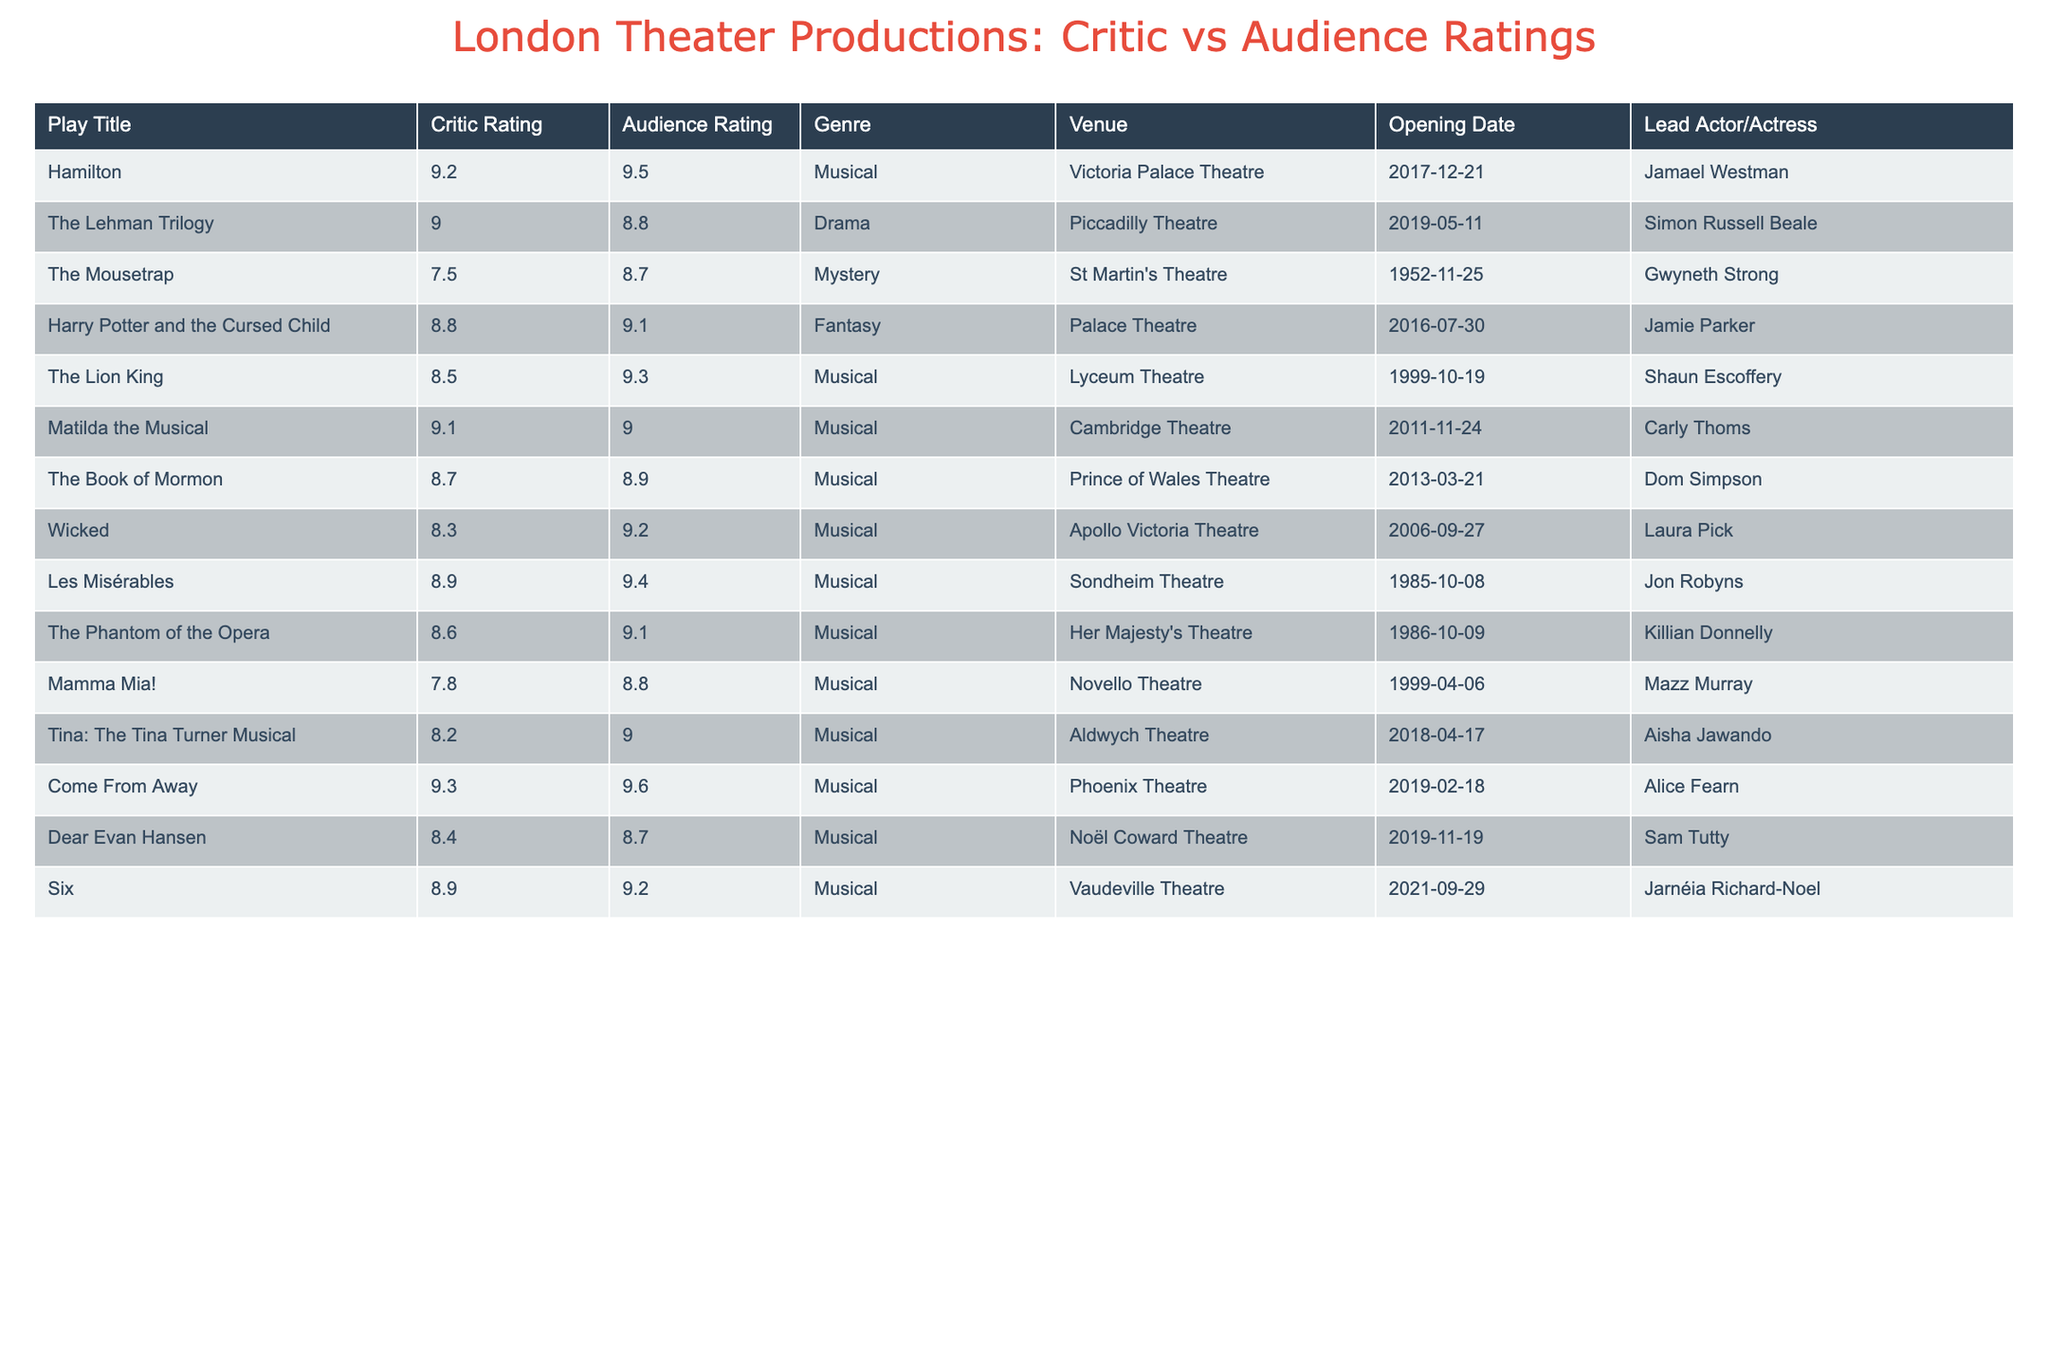What is the highest critic rating among the listed plays? The highest critic rating is found by looking at the Critic Rating column and identifying the maximum value, which is 9.3 for "Come From Away."
Answer: 9.3 Which play has the lowest audience rating? The lowest audience rating can be found in the Audience Rating column. The play with the lowest value is "Mamma Mia!" with a rating of 8.8.
Answer: 8.8 Is the audience rating for "The Lion King" higher than 9.0? Checking the Audience Rating for "The Lion King," it is 9.3, which is indeed higher than 9.0.
Answer: Yes What is the difference between the critic rating and audience rating for "The Lehman Trilogy"? For "The Lehman Trilogy," the critic rating is 9.0 and the audience rating is 8.8. The difference can be calculated as 9.0 - 8.8 = 0.2.
Answer: 0.2 Which genre has the highest average critic rating? To find the average critic rating by genre, we need to sum the critic ratings for each genre and then divide by the number of plays in that genre. The averages are: Musicals = 8.74, Drama = 9.00, Mystery = 7.5, Fantasy = 8.8. The highest average is for Drama.
Answer: Drama What is the audience rating for "Harry Potter and the Cursed Child"? The Audience Rating for "Harry Potter and the Cursed Child" is explicitly stated in the table as 9.1.
Answer: 9.1 Are there any plays where the audience rating is greater than the critic rating? We can compare the values of Critic and Audience Ratings across all plays. The plays "Come From Away," "Hamilton," "Harry Potter and the Cursed Child," "Les Misérables," "The Lion King," "Mamma Mia!," "Six," and "Tina: The Tina Turner Musical" show audience ratings greater than their critic ratings.
Answer: Yes Which play features a lead actor or actress named "Laura Pick"? Referring to the Lead Actor/Actress column, "Wicked" features Laura Pick in the lead role.
Answer: Wicked What is the median critic rating of all the plays listed? We need to arrange the Critic Ratings in ascending order and find the median value. The ratings sorted are: 7.5, 7.8, 8.2, 8.3, 8.4, 8.5, 8.6, 8.7, 8.8, 8.9, 9.0, 9.1, 9.2, 9.3. With 14 values, the median is the average of the 7th and 8th values: (8.6 + 8.7) / 2 = 8.65.
Answer: 8.65 How many musicals have an audience rating of 9.0 or higher? By checking the Audience Ratings for all musicals, we find that the musicals with ratings of 9.0 or above are: "Hamilton," "Harry Potter and the Cursed Child," "The Lion King," "Come From Away," "Les Misérables," "The Phantom of the Opera," "Six," and "Tina: The Tina Turner Musical." This gives us a total of 8 musicals.
Answer: 8 